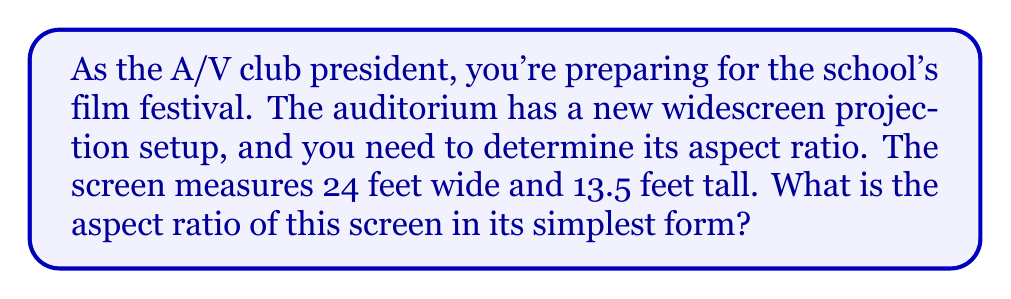Can you solve this math problem? To find the aspect ratio of a screen, we need to compare its width to its height. The aspect ratio is typically expressed as width:height.

Given:
- Screen width = 24 feet
- Screen height = 13.5 feet

Step 1: Express the ratio of width to height.
$$\text{Aspect ratio} = \frac{\text{width}}{\text{height}} = \frac{24}{13.5}$$

Step 2: Simplify the fraction by dividing both the numerator and denominator by their greatest common divisor (GCD).
To find the GCD, we can use the Euclidean algorithm:
24 = 1 × 13.5 + 10.5
13.5 = 1 × 10.5 + 3
10.5 = 3 × 3 + 1.5
3 = 2 × 1.5

The GCD is 1.5.

Now, divide both numbers by 1.5:
$$\frac{24 \div 1.5}{13.5 \div 1.5} = \frac{16}{9}$$

Step 3: Express the result as a ratio.
The simplified aspect ratio is 16:9.

This 16:9 aspect ratio is a common widescreen format used in modern HD televisions and many films, making it suitable for your school's film festival.
Answer: The aspect ratio of the screen is 16:9. 